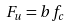<formula> <loc_0><loc_0><loc_500><loc_500>F _ { u } = b f _ { c }</formula> 